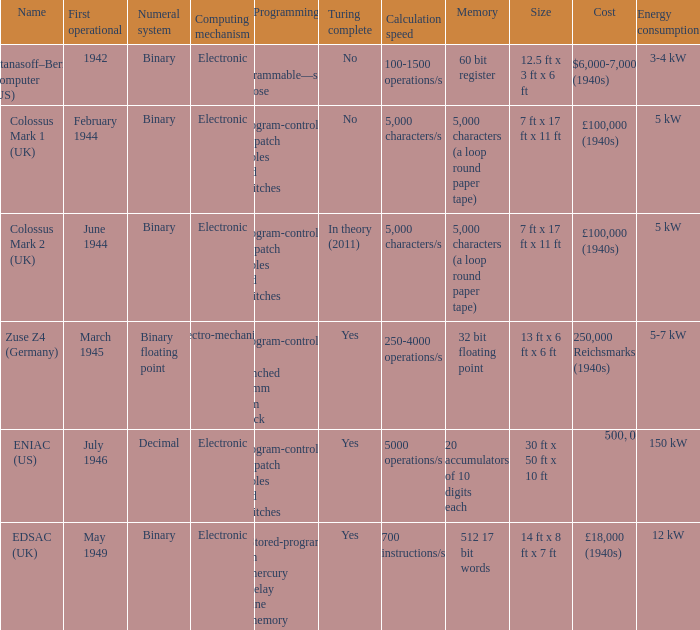What's the turing complete with name being atanasoff–berry computer (us) No. 